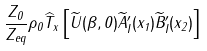Convert formula to latex. <formula><loc_0><loc_0><loc_500><loc_500>\frac { Z _ { 0 } } { Z _ { e q } } \rho _ { 0 } \widehat { T } _ { x } \left [ \widetilde { U } ( \beta , 0 ) \widetilde { A } _ { I } ^ { \prime } ( x _ { 1 } ) \widetilde { B } _ { I } ^ { \prime } ( x _ { 2 } ) \right ]</formula> 